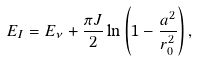Convert formula to latex. <formula><loc_0><loc_0><loc_500><loc_500>E _ { I } = E _ { \nu } + \frac { \pi J } { 2 } \ln \left ( 1 - \frac { a ^ { 2 } } { r _ { 0 } ^ { 2 } } \right ) ,</formula> 